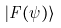<formula> <loc_0><loc_0><loc_500><loc_500>| F ( \psi ) \rangle</formula> 